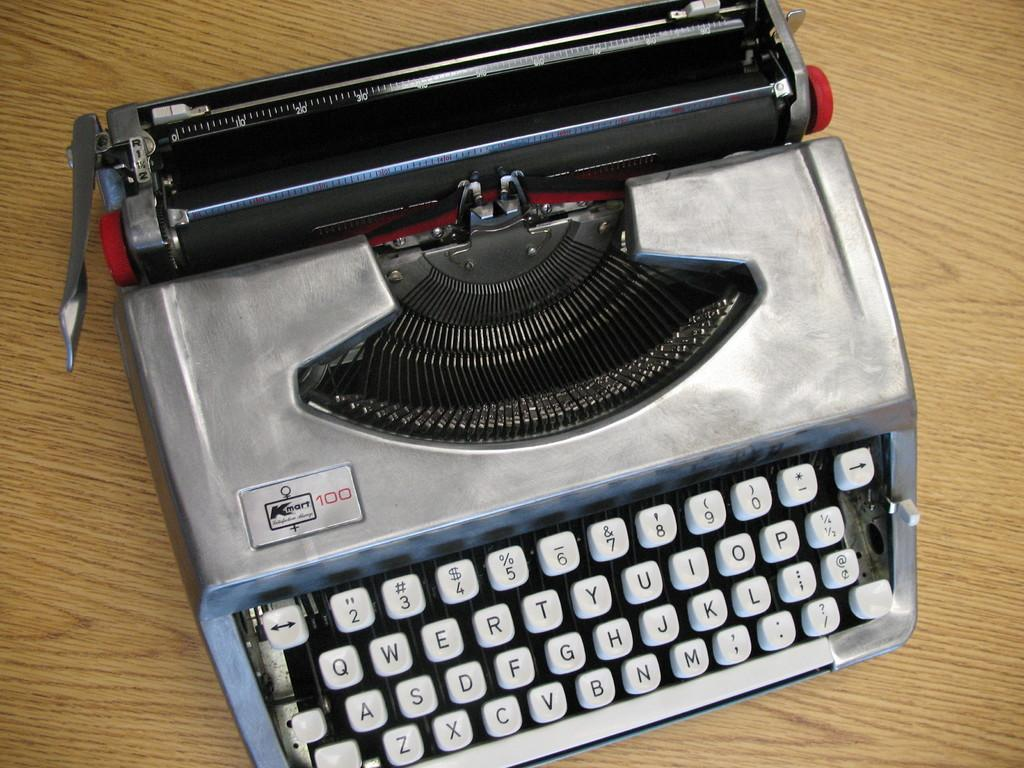<image>
Relay a brief, clear account of the picture shown. A Kmart 100 typewriter is silver with white keys. 